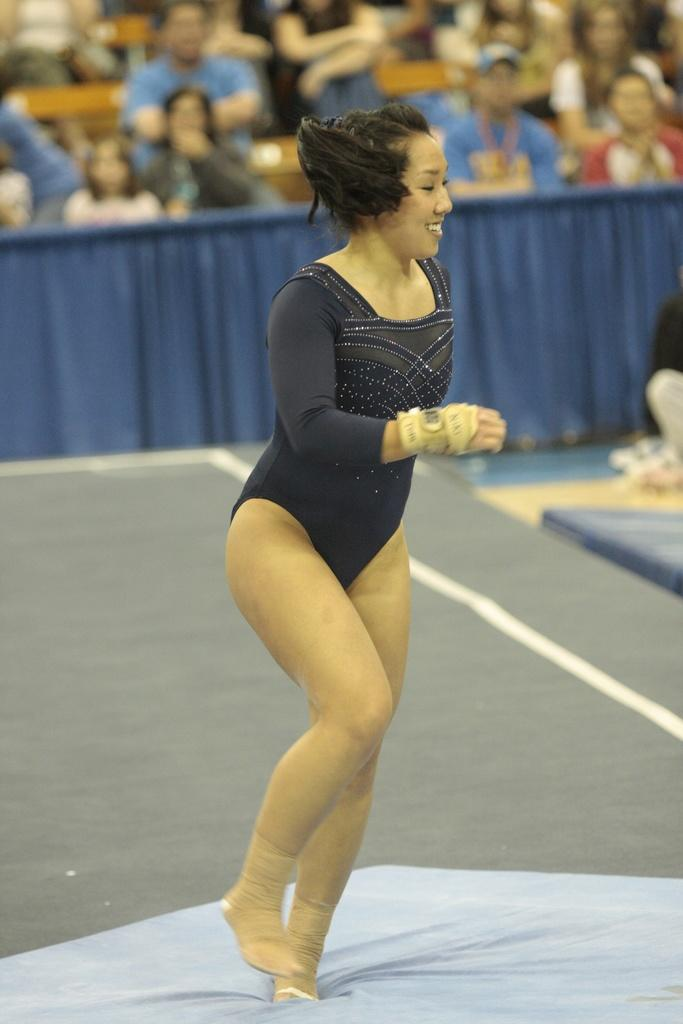Who is the main subject in the image? There is a lady in the center of the image. What is the lady doing in the image? The lady is standing and smiling. What can be seen in the background of the image? There are people sitting and tables visible in the background of the image. What type of decoration or covering is present in the background? There is a curtain in the background of the image. What type of authority does the lady have in the image? There is no indication of the lady having any authority in the image. What flavor of celery can be seen in the image? There is no celery present in the image. 